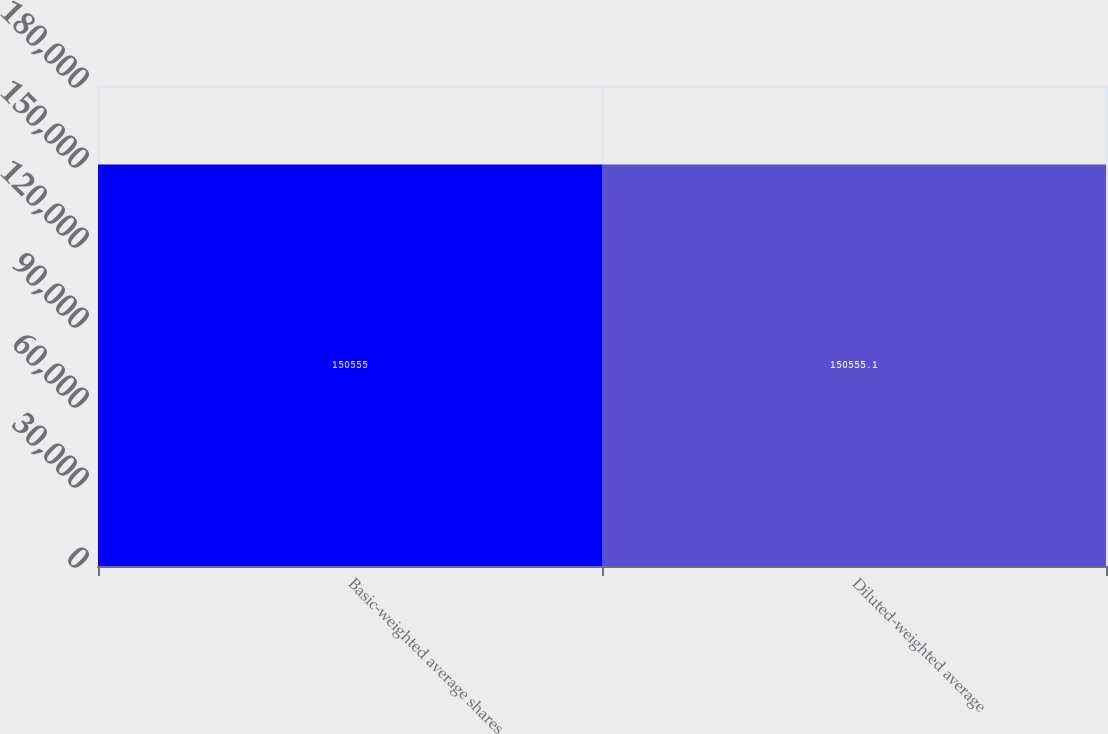Convert chart to OTSL. <chart><loc_0><loc_0><loc_500><loc_500><bar_chart><fcel>Basic-weighted average shares<fcel>Diluted-weighted average<nl><fcel>150555<fcel>150555<nl></chart> 